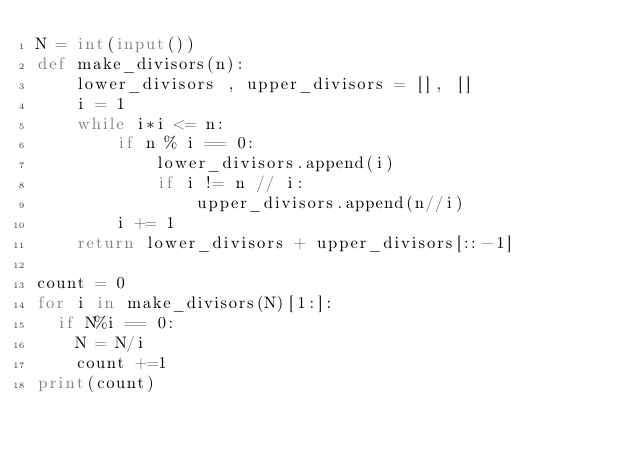<code> <loc_0><loc_0><loc_500><loc_500><_Python_>N = int(input())
def make_divisors(n):
    lower_divisors , upper_divisors = [], []
    i = 1
    while i*i <= n:
        if n % i == 0:
            lower_divisors.append(i)
            if i != n // i:
                upper_divisors.append(n//i)
        i += 1
    return lower_divisors + upper_divisors[::-1]

count = 0
for i in make_divisors(N)[1:]:
  if N%i == 0:
    N = N/i
    count +=1
print(count)</code> 